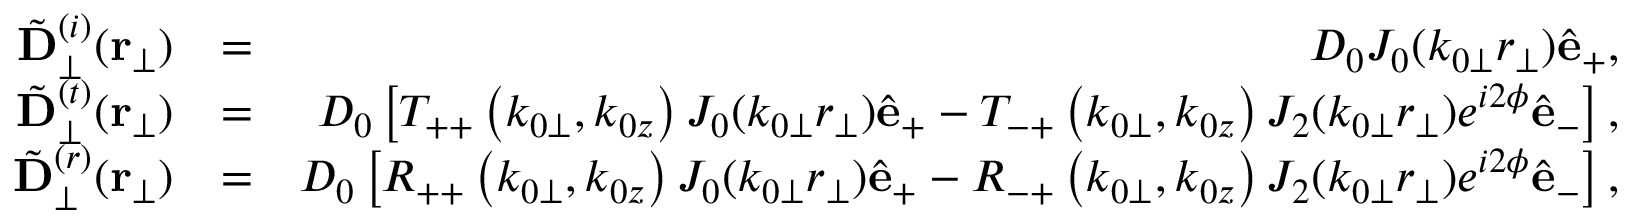Convert formula to latex. <formula><loc_0><loc_0><loc_500><loc_500>\begin{array} { r l r } { { \tilde { D } } _ { \perp } ^ { ( i ) } ( { r } _ { \perp } ) } & { = } & { D _ { 0 } J _ { 0 } ( k _ { 0 \perp } r _ { \perp } ) \hat { e } _ { + } , } \\ { { \tilde { D } } _ { \perp } ^ { ( t ) } ( { r } _ { \perp } ) } & { = } & { D _ { 0 } \left [ T _ { + + } \left ( k _ { 0 \perp } , k _ { 0 z } \right ) J _ { 0 } ( k _ { 0 \perp } r _ { \perp } ) \hat { e } _ { + } - T _ { - + } \left ( k _ { 0 \perp } , k _ { 0 z } \right ) J _ { 2 } ( k _ { 0 \perp } r _ { \perp } ) e ^ { i 2 \phi } \hat { e } _ { - } \right ] , } \\ { { \tilde { D } } _ { \perp } ^ { ( r ) } ( { r } _ { \perp } ) } & { = } & { D _ { 0 } \left [ R _ { + + } \left ( k _ { 0 \perp } , k _ { 0 z } \right ) J _ { 0 } ( k _ { 0 \perp } r _ { \perp } ) \hat { e } _ { + } - R _ { - + } \left ( k _ { 0 \perp } , k _ { 0 z } \right ) J _ { 2 } ( k _ { 0 \perp } r _ { \perp } ) e ^ { i 2 \phi } \hat { e } _ { - } \right ] , } \end{array}</formula> 